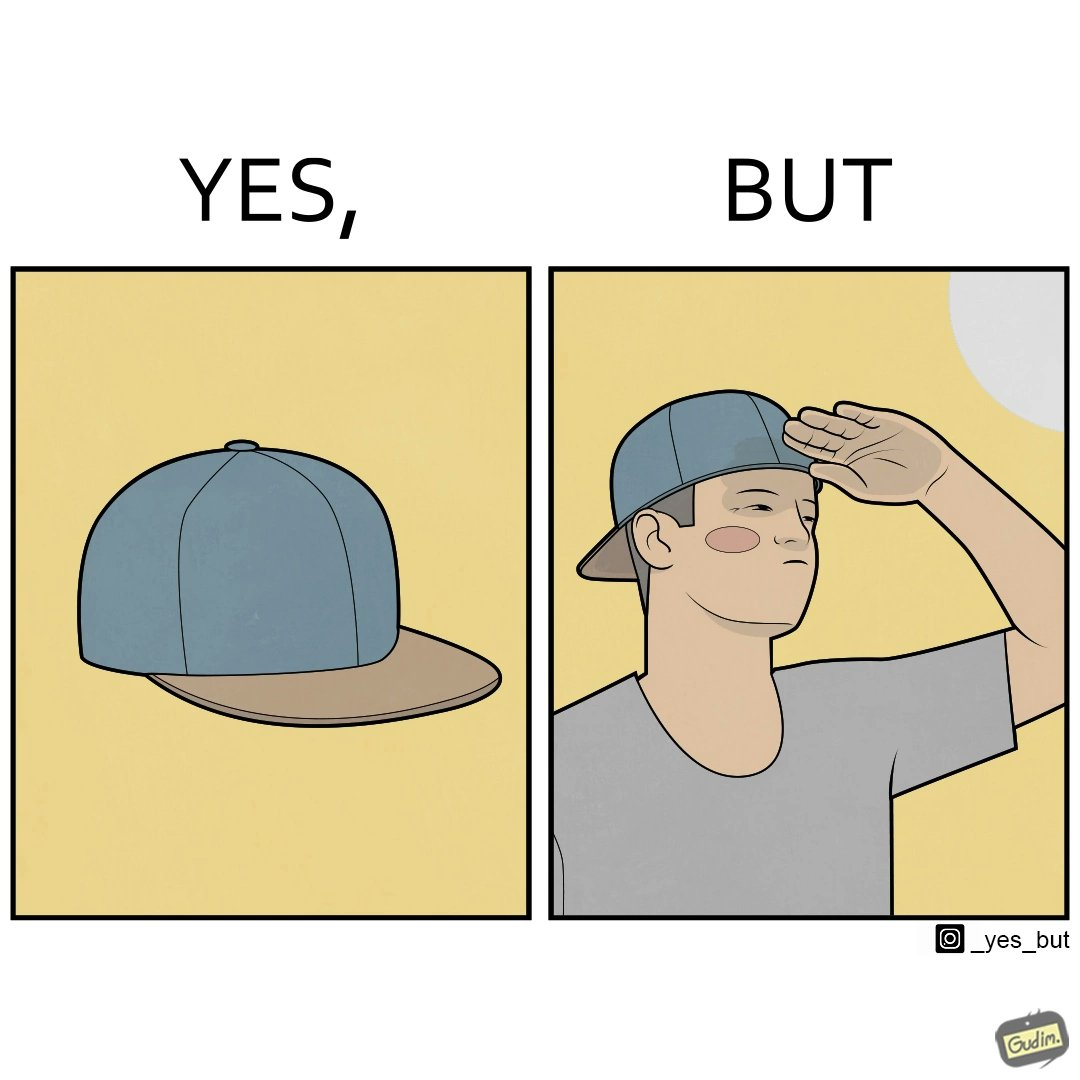Is there satirical content in this image? Yes, this image is satirical. 